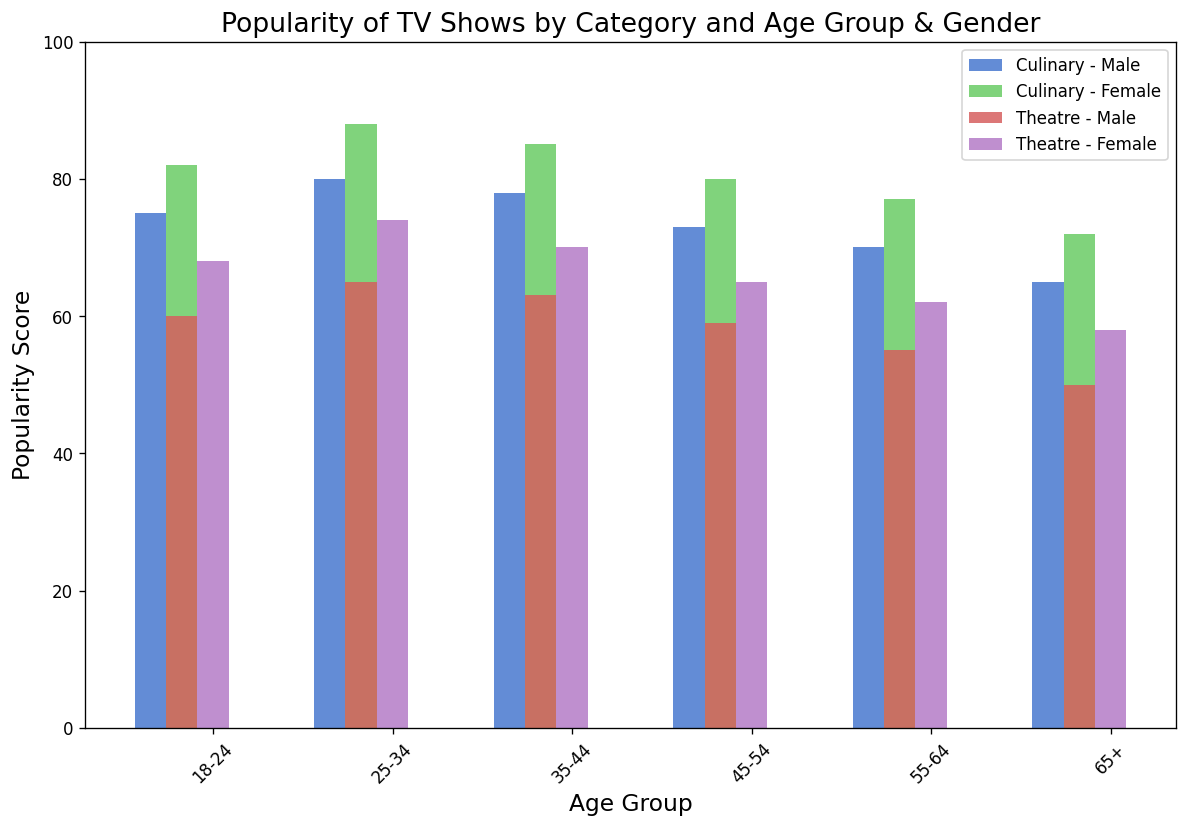Which age group has the highest popularity score for culinary TV shows among females? To find the highest popularity score for culinary TV shows among females, look for the tallest bar in the female section across different age groups labeled as "Culinary". The tallest bar is for the 25-34 age group with a popularity score of 88.
Answer: 25-34 Which gender has a higher popularity score for theatre TV shows in the 18-24 age group? Compare the heights of the bars for male and female viewers in the 18-24 age group for theatre TV shows. The bar for females is taller, indicating a higher popularity score.
Answer: Female What is the average popularity score for culinary TV shows across all age groups for males? Sum the popularity scores for males for each age group in the culinary category: (75 + 80 + 78 + 73 + 70 + 65) = 441. There are 6 age groups, so the average score is 441/6 = 73.5.
Answer: 73.5 By how much does the popularity score of culinary TV shows for the 35-44 age group differ between males and females? Find the difference in popularity scores between males and females in the 35-44 age group for culinary TV shows. For males, the score is 78, and for females, it is 85. The difference is 85 - 78 = 7.
Answer: 7 Which category and gender combination has the lowest popularity score for the 65+ age group? Identify the shortest bar among all category and gender combinations for the 65+ age group. The shortest bar is for theatre TV shows among males, with a popularity score of 50.
Answer: Theatre, Male Which age group shows the largest difference in popularity between culinary and theatre TV shows for females? Compute the differences in popularity scores between culinary and theatre TV shows for females in each age group: (82-68)=14, (88-74)=14, (85-70)=15, (80-65)=15, (77-62)=15, (72-58)=14. The largest difference is for the 35-64 age groups (all with a difference of 15).
Answer: 35-64 What is the combined popularity score for culinary and theatre TV shows for the 55-64 age group for females? Add up the popularity scores for culinary and theatre TV shows for females in the 55-64 age group: 77 (culinary) + 62 (theatre) = 139.
Answer: 139 In which age group do males prefer culinary TV shows more than theatre TV shows by the largest margin? Calculate the difference between the popularity scores for culinary and theatre TV shows for males in each age group: (75-60)=15, (80-65)=15, (78-63)=15, (73-59)=14, (70-55)=15, (65-50)=15. The largest margin is 15, observed in multiple age groups: 18-24, 25-34, 35-44, 55-64, and 65+.
Answer: 18-24, 25-34, 35-44, 55-64, 65+ What is the difference in the popularity scores between the youngest and oldest age groups for theatre TV shows among females? Determine the popularity scores for the youngest (18-24) age group and the oldest (65+) age group for theatre TV shows among females. The scores are 68 and 58, respectively. The difference is 68 - 58 = 10.
Answer: 10 Between males and females in all age groups combined, which gender shows a higher overall interest in theatre TV shows? Sum the popularity scores for theatre TV shows for all age groups for each gender. Males: (60+65+63+59+55+50) = 352. Females: (68+74+70+65+62+58) = 397. Females have a higher overall interest with a total score of 397.
Answer: Females 